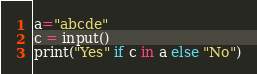Convert code to text. <code><loc_0><loc_0><loc_500><loc_500><_Python_>a="abcde"
c = input()
print("Yes" if c in a else "No")</code> 